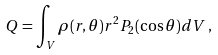Convert formula to latex. <formula><loc_0><loc_0><loc_500><loc_500>Q = \int _ { V } \rho ( r , \theta ) r ^ { 2 } P _ { 2 } ( \cos \theta ) d V \, ,</formula> 